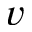Convert formula to latex. <formula><loc_0><loc_0><loc_500><loc_500>v</formula> 